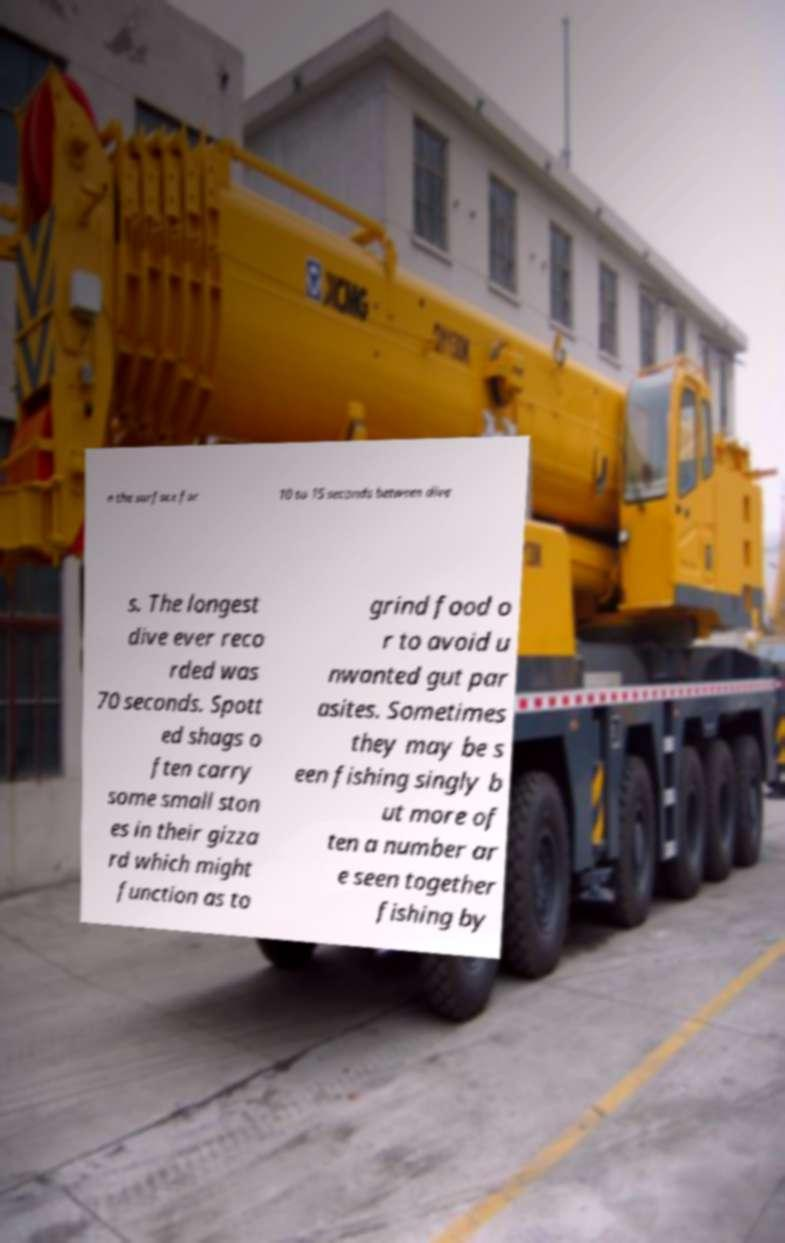Could you extract and type out the text from this image? n the surface for 10 to 15 seconds between dive s. The longest dive ever reco rded was 70 seconds. Spott ed shags o ften carry some small ston es in their gizza rd which might function as to grind food o r to avoid u nwanted gut par asites. Sometimes they may be s een fishing singly b ut more of ten a number ar e seen together fishing by 